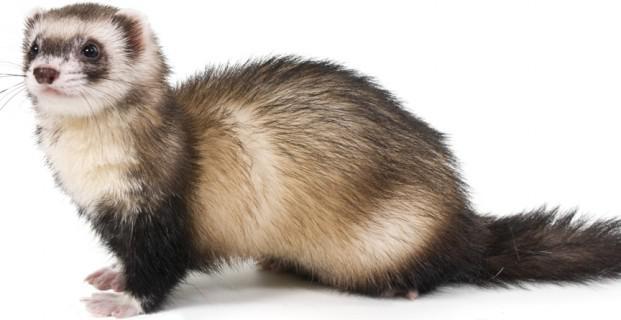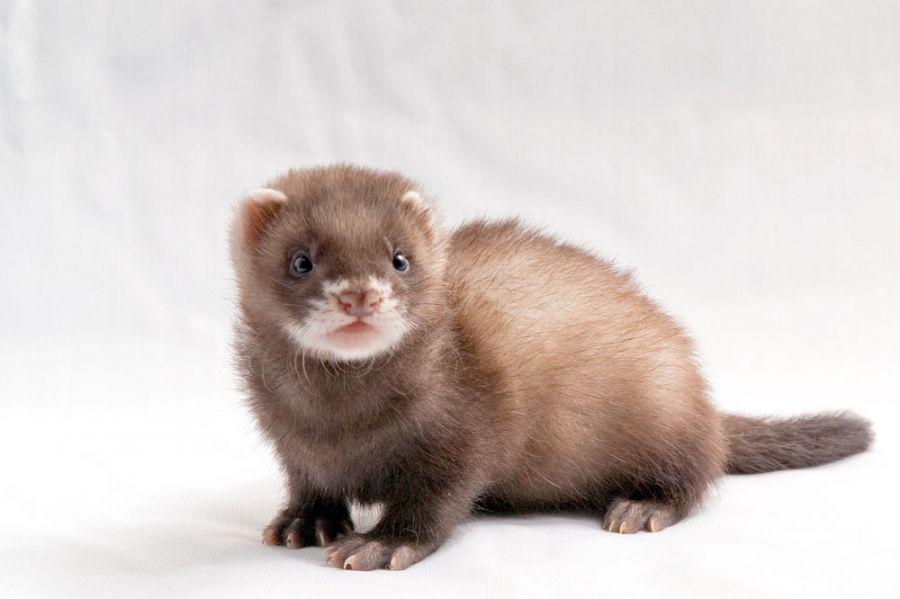The first image is the image on the left, the second image is the image on the right. Examine the images to the left and right. Is the description "There is exactly one human hand next to at least one upright ferret." accurate? Answer yes or no. No. The first image is the image on the left, the second image is the image on the right. Assess this claim about the two images: "There is exactly two ferrets.". Correct or not? Answer yes or no. Yes. 